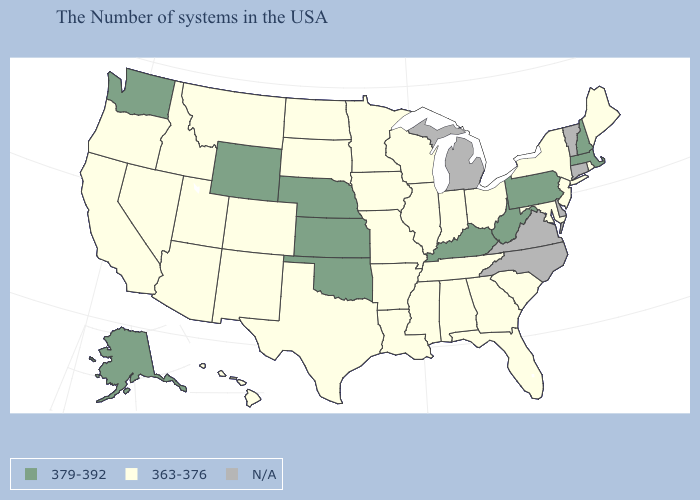What is the value of North Dakota?
Keep it brief. 363-376. What is the value of Colorado?
Give a very brief answer. 363-376. What is the highest value in the MidWest ?
Quick response, please. 379-392. What is the value of Virginia?
Answer briefly. N/A. Among the states that border Wyoming , which have the highest value?
Write a very short answer. Nebraska. Does Oklahoma have the highest value in the South?
Write a very short answer. Yes. What is the lowest value in the USA?
Answer briefly. 363-376. What is the value of Oregon?
Give a very brief answer. 363-376. Among the states that border Iowa , does Nebraska have the lowest value?
Concise answer only. No. How many symbols are there in the legend?
Keep it brief. 3. Which states hav the highest value in the Northeast?
Concise answer only. Massachusetts, New Hampshire, Pennsylvania. What is the lowest value in states that border Wyoming?
Give a very brief answer. 363-376. What is the lowest value in the USA?
Write a very short answer. 363-376. Which states have the highest value in the USA?
Be succinct. Massachusetts, New Hampshire, Pennsylvania, West Virginia, Kentucky, Kansas, Nebraska, Oklahoma, Wyoming, Washington, Alaska. 